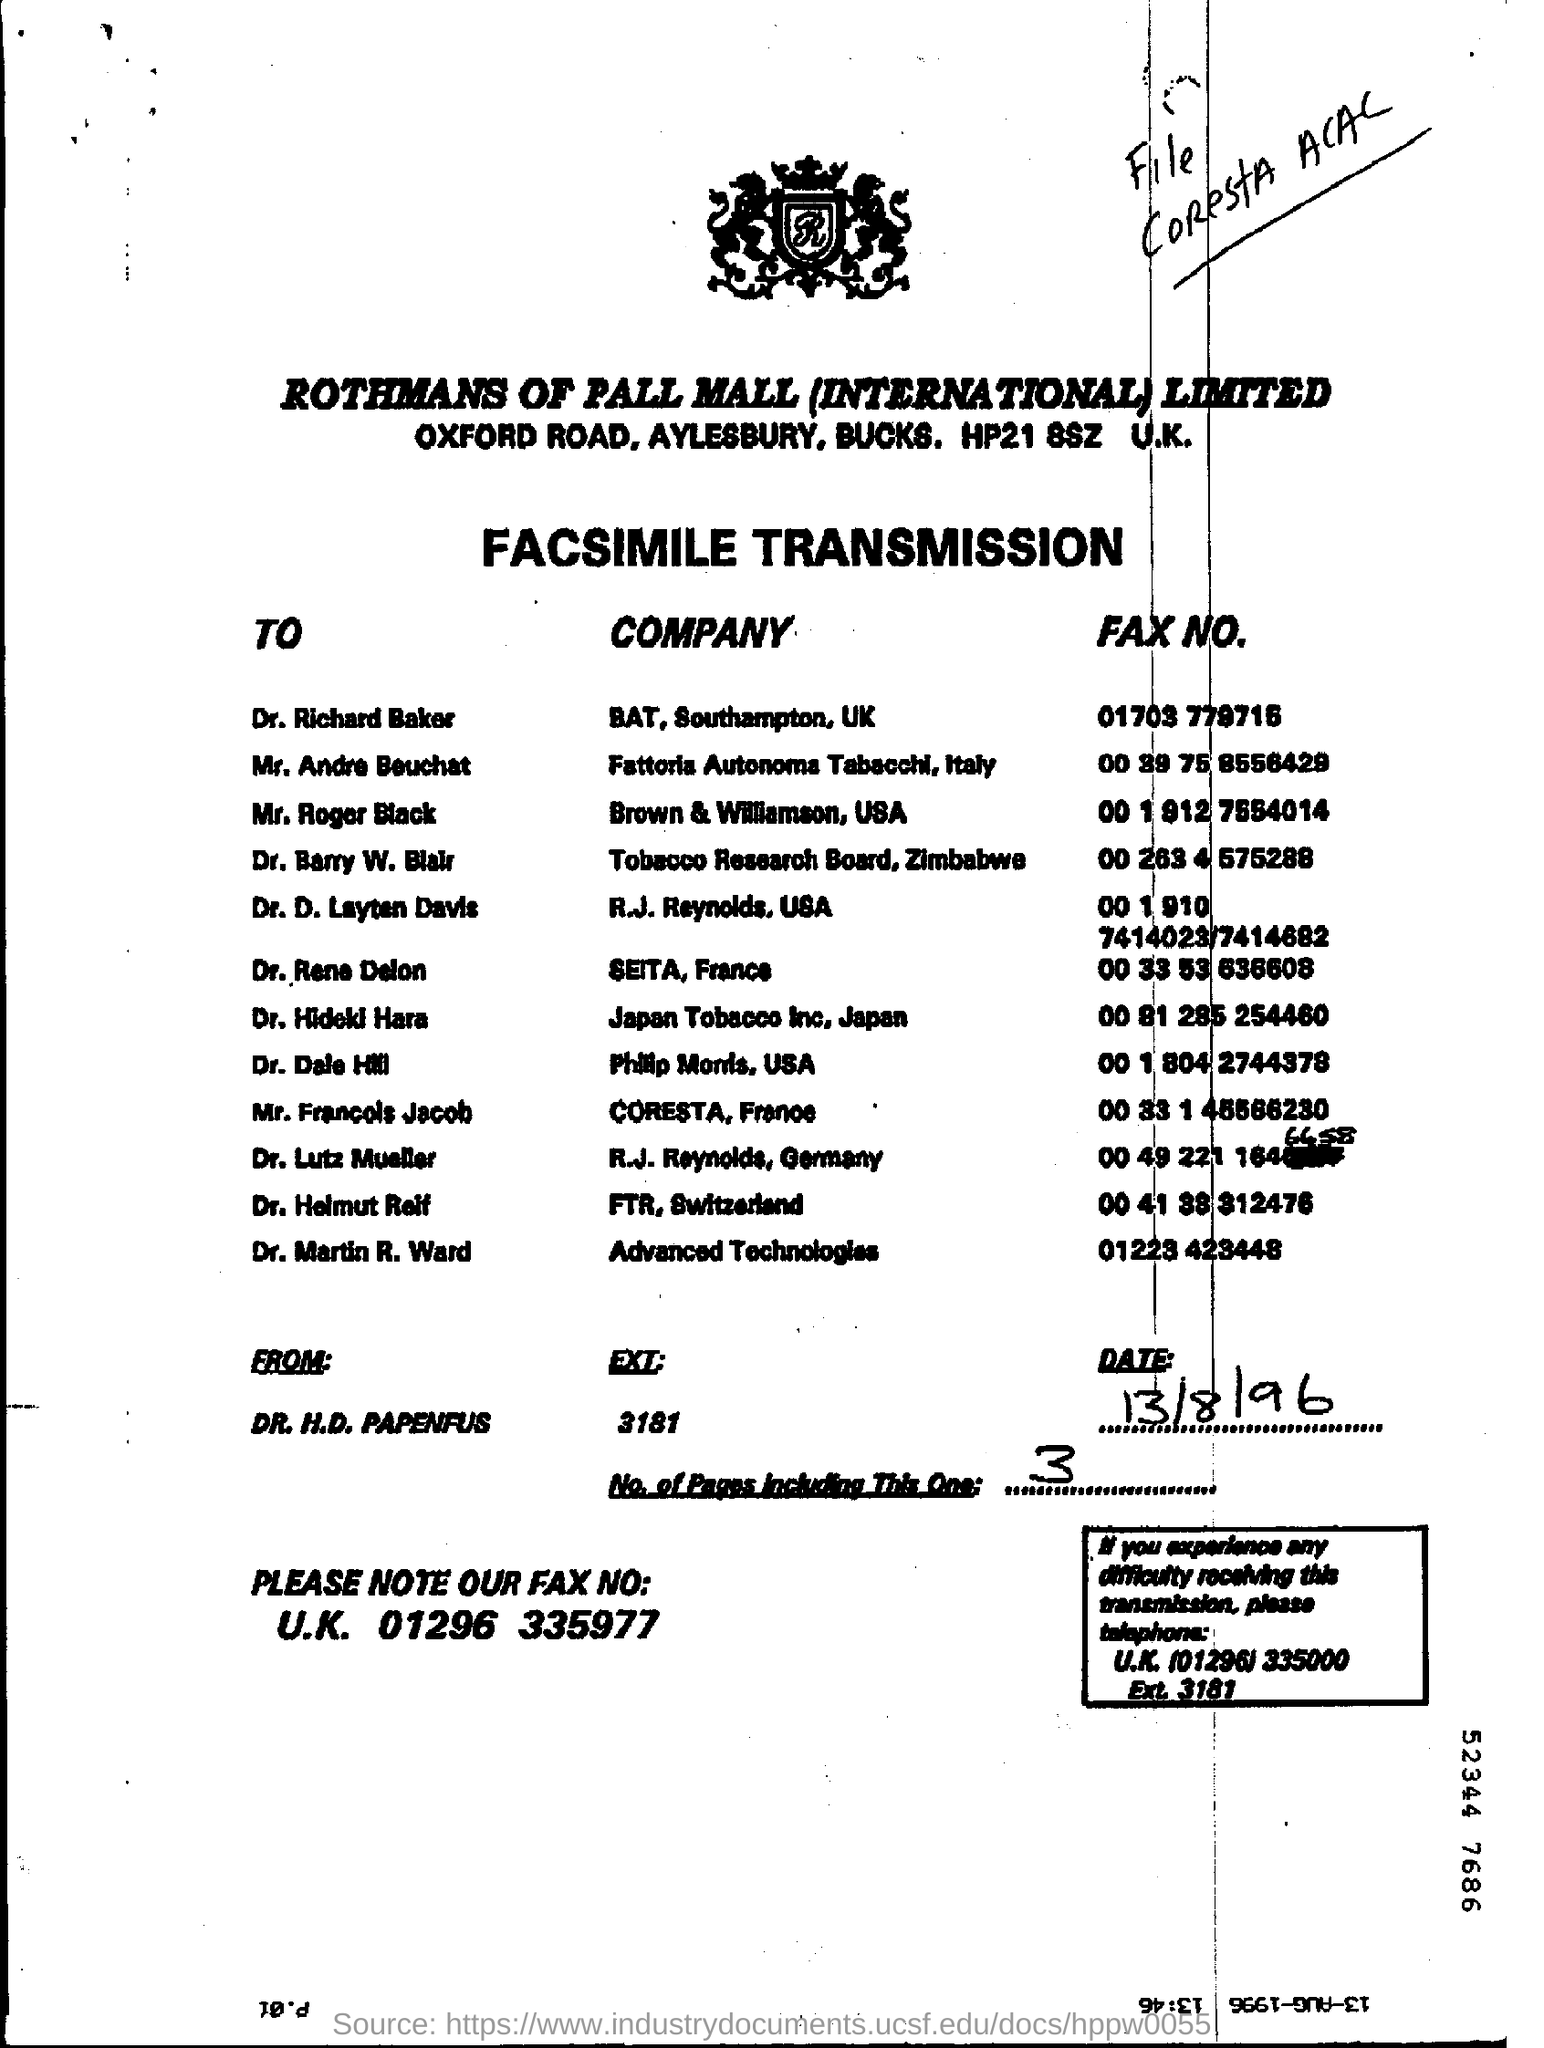Specify some key components in this picture. The date mentioned is August 13, 1996. 